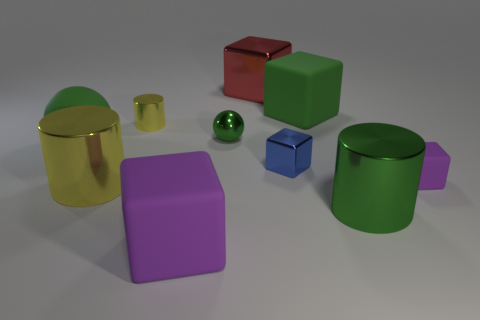Could you describe the lighting and shadows in the picture? The lighting in the image appears to be diffused, with soft shadows cast to the right of the objects. This suggests a source of light coming from the top left side, not directly visible in the image. 